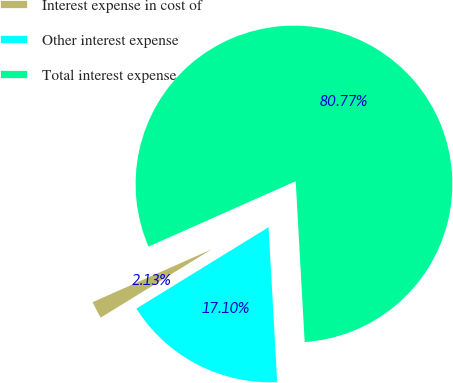<chart> <loc_0><loc_0><loc_500><loc_500><pie_chart><fcel>Interest expense in cost of<fcel>Other interest expense<fcel>Total interest expense<nl><fcel>2.13%<fcel>17.1%<fcel>80.77%<nl></chart> 